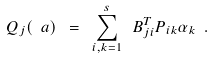<formula> <loc_0><loc_0><loc_500><loc_500>Q _ { j } ( \ a ) \ = \ \sum _ { i , k = 1 } ^ { s } \ B ^ { T } _ { j i } P _ { i k } \alpha _ { k } \ .</formula> 